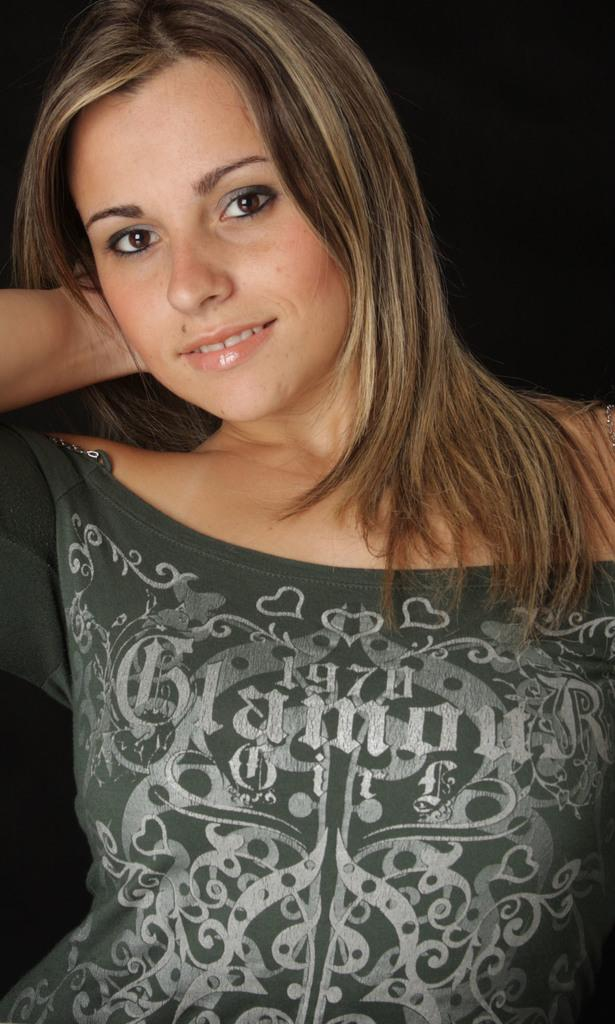Who is the main subject in the image? There is a woman in the image. What is the woman doing in the image? The woman is standing and posing for the camera. What is the woman wearing in the image? The woman is wearing a green dress. Can you describe the design on the green dress? The green dress has designs on it. What theory does the woman in the image support? There is no information about the woman's support for any theory in the image. What songs is the woman singing in the image? There is no indication that the woman is singing any songs in the image. 